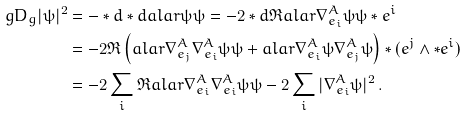<formula> <loc_0><loc_0><loc_500><loc_500>\ g D _ { g } | \psi | ^ { 2 } & = - * d * d a l a r { \psi } { \psi } = - 2 * d \Re a l a r { \nabla ^ { A } _ { e _ { i } } \psi } { \psi } * e ^ { i } \\ & = - 2 \Re \left ( a l a r { \nabla ^ { A } _ { e _ { j } } \nabla ^ { A } _ { e _ { i } } \psi } { \psi } + a l a r { \nabla ^ { A } _ { e _ { i } } \psi } { \nabla ^ { A } _ { e _ { j } } \psi } \right ) * ( e ^ { j } \wedge * e ^ { i } ) \\ & = - 2 \sum _ { i } \Re a l a r { \nabla ^ { A } _ { e _ { i } } \nabla ^ { A } _ { e _ { i } } \psi } { \psi } - 2 \sum _ { i } | \nabla ^ { A } _ { e _ { i } } \psi | ^ { 2 } \, .</formula> 